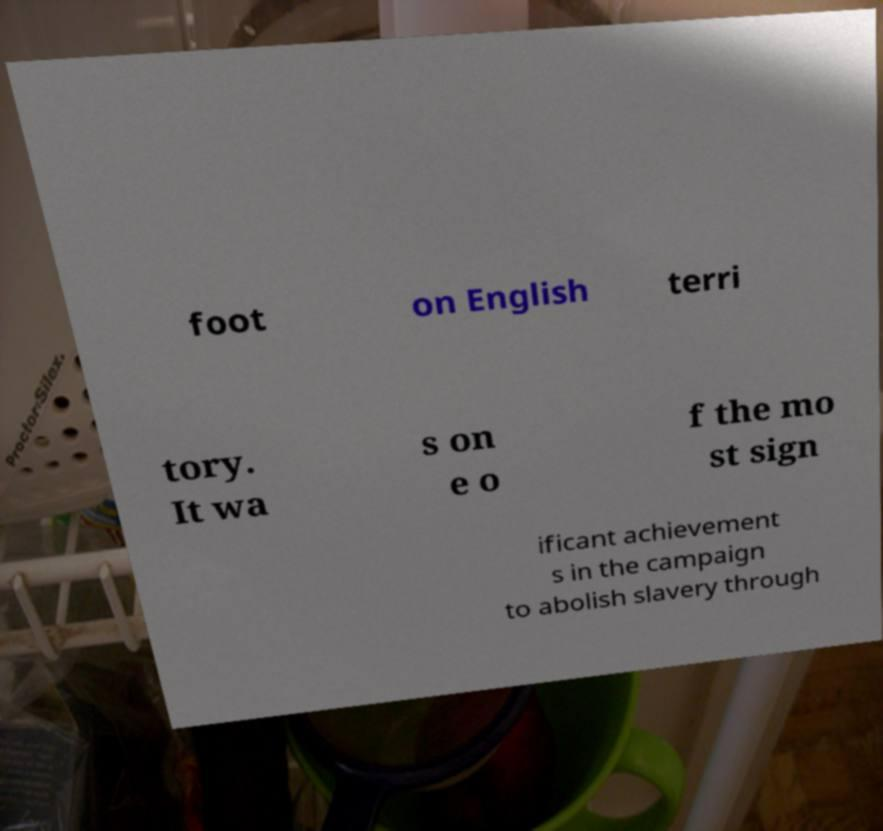There's text embedded in this image that I need extracted. Can you transcribe it verbatim? foot on English terri tory. It wa s on e o f the mo st sign ificant achievement s in the campaign to abolish slavery through 